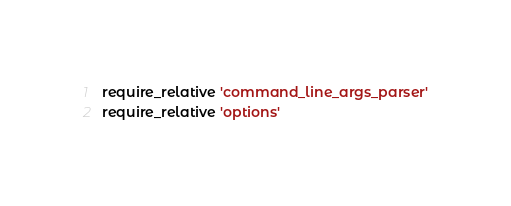Convert code to text. <code><loc_0><loc_0><loc_500><loc_500><_Ruby_>require_relative 'command_line_args_parser'
require_relative 'options'</code> 